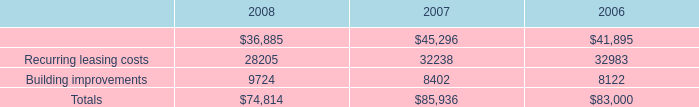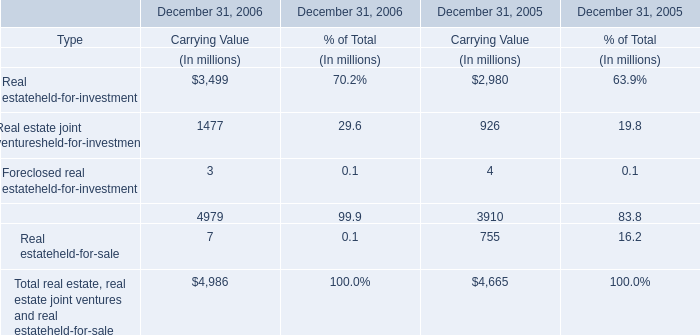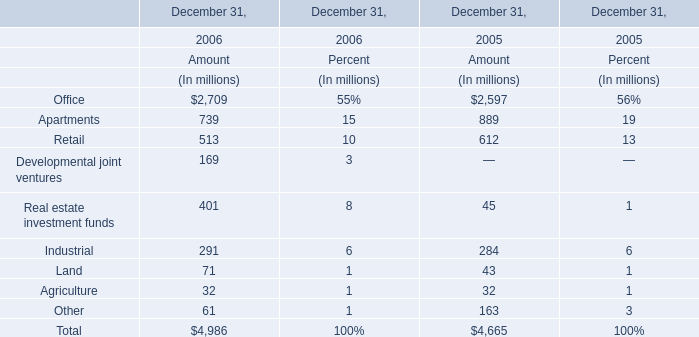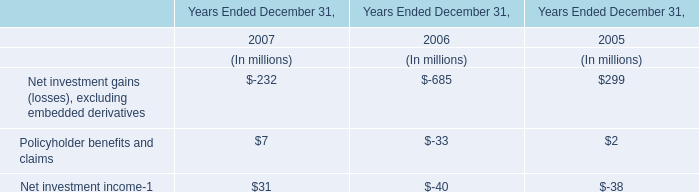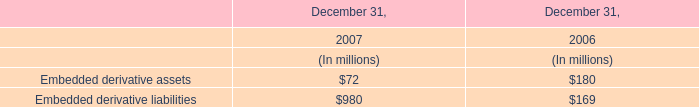What is the growing rate of Carrying Value of Real estateheld-for-investment in the year with the least Carrying Value of Real estateheld-for-sale? 
Computations: ((3499 - 2980) / 2980)
Answer: 0.17416. 